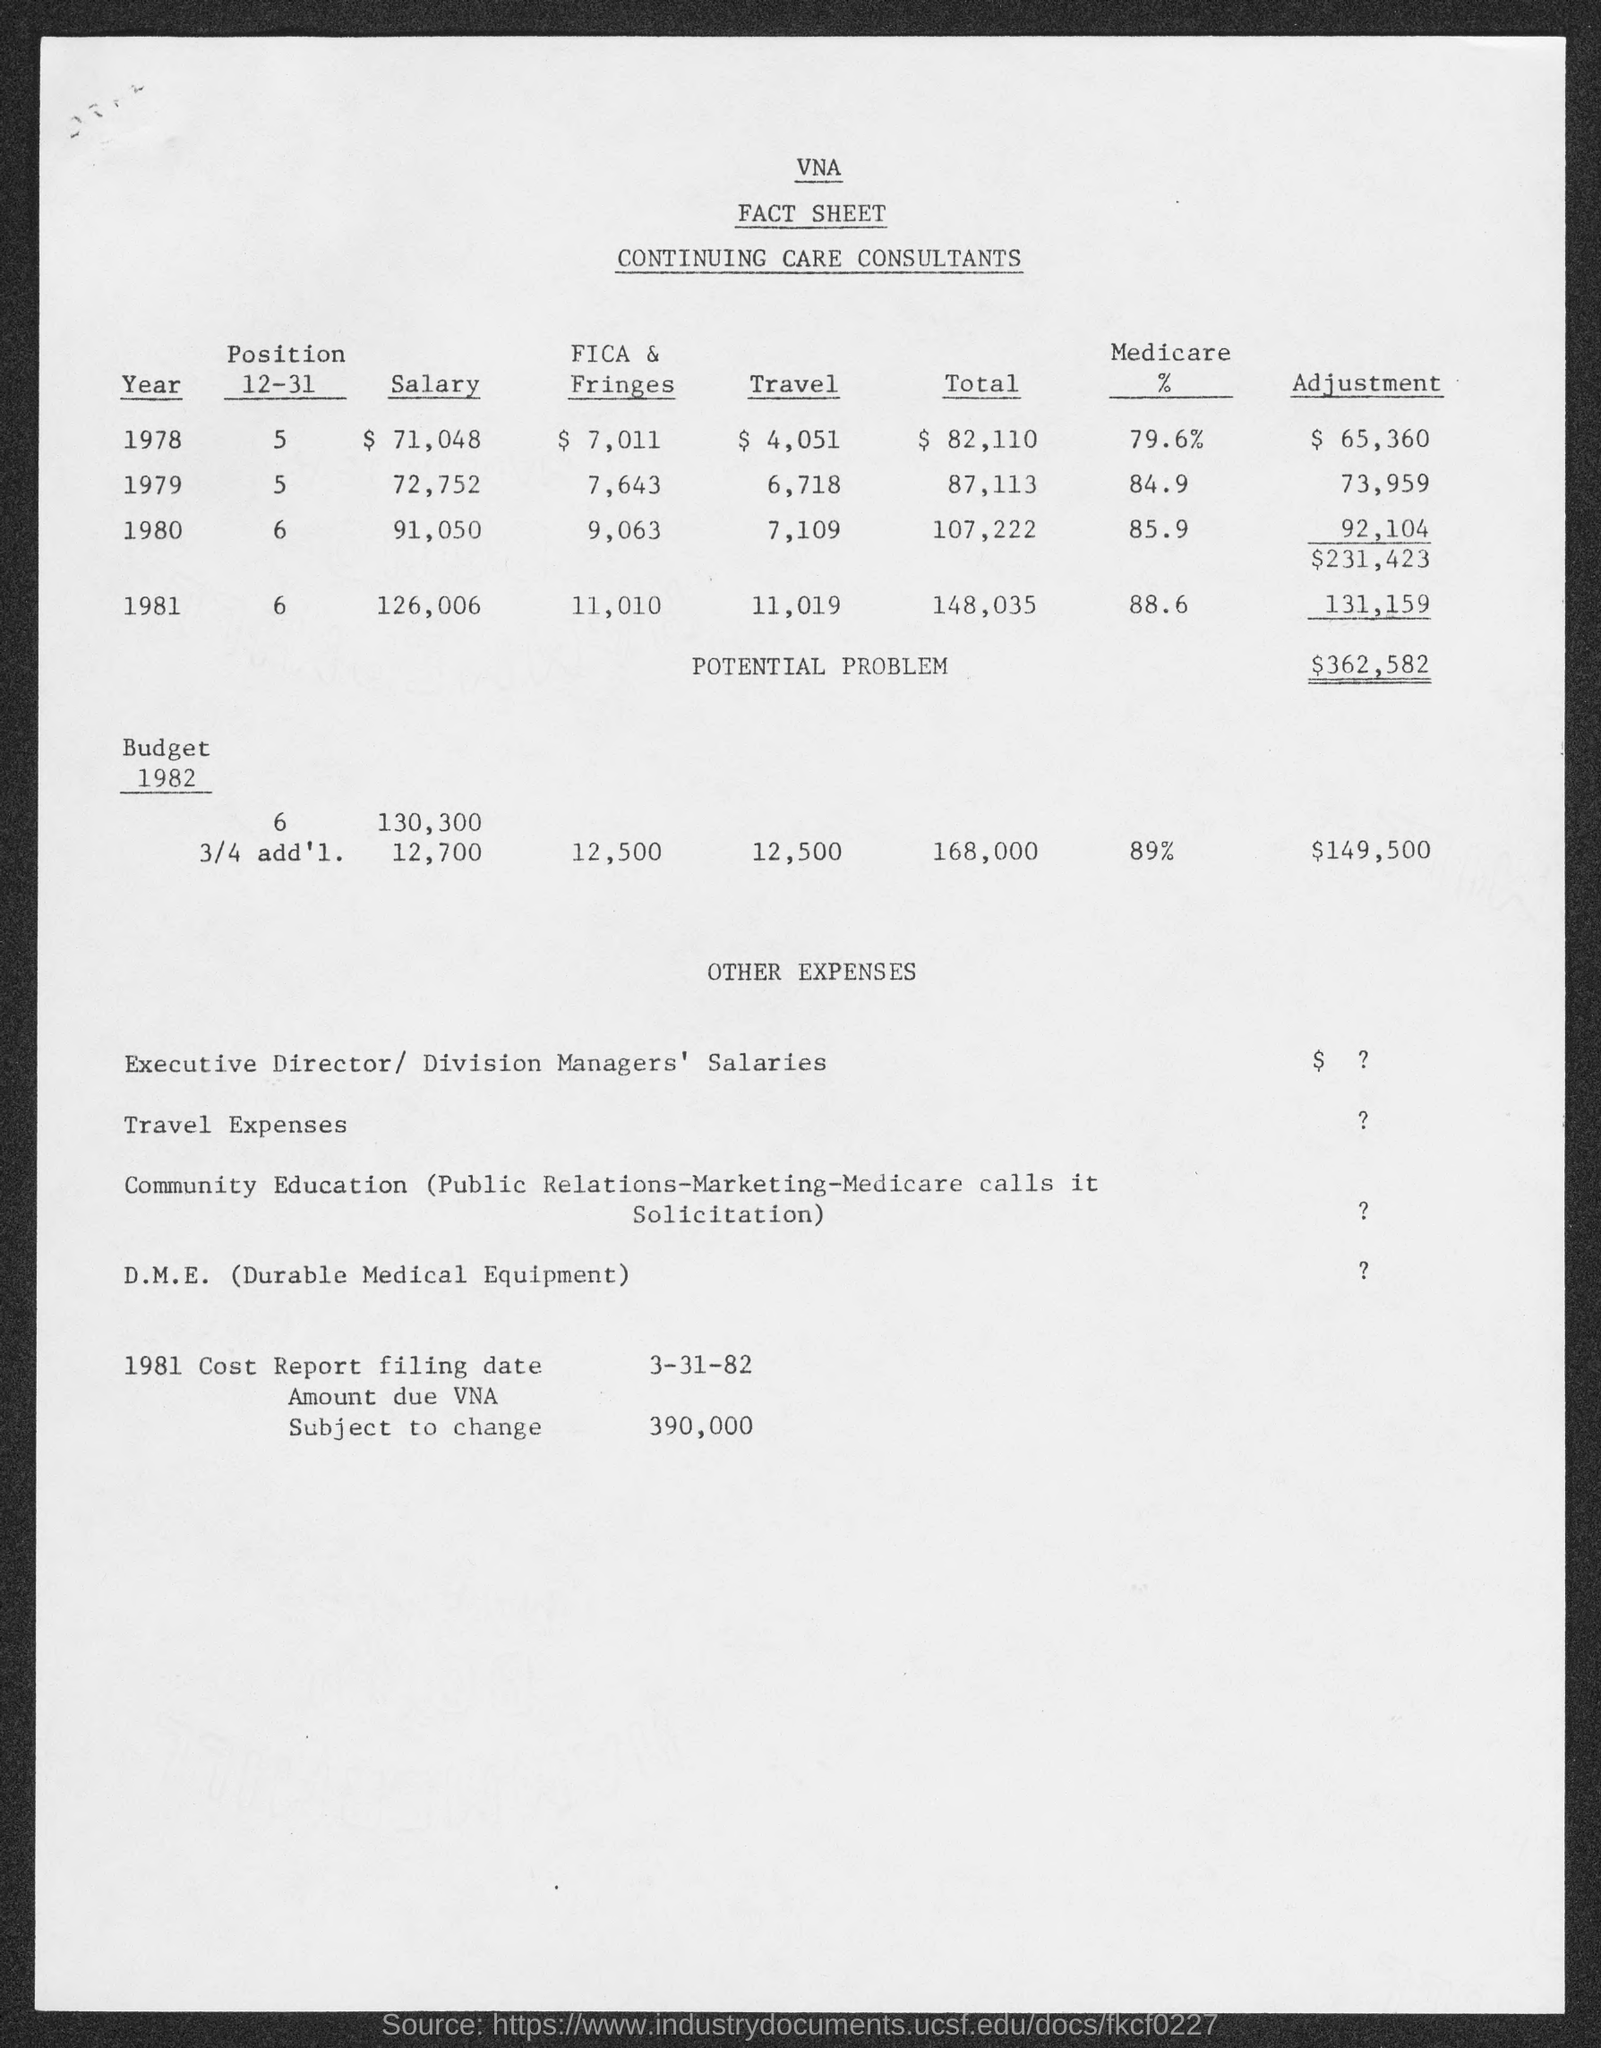What is the heading of the first column of first table?
Give a very brief answer. Year. What is the first "year" entered?
Your answer should be compact. 1978. What is the "Adjustment" amount for 1978 Year?
Your answer should be very brief. $ 65,360. Mention the total "POTENTIAL PROBLEM" amount?
Ensure brevity in your answer.  $362,582. What is the expansion of D.M.E?
Ensure brevity in your answer.  Durable Medical Equipment. Mention "1981 Cost Report filing date"?
Offer a very short reply. 3-31-82. What is the"Amount due VNA Subject to change"?
Make the answer very short. 390,000. What is the "Salary" amount for 1978 Year?
Offer a very short reply. $ 71,048. Mention the "Travel" expenses for the Year 1980?
Make the answer very short. 7,109. 